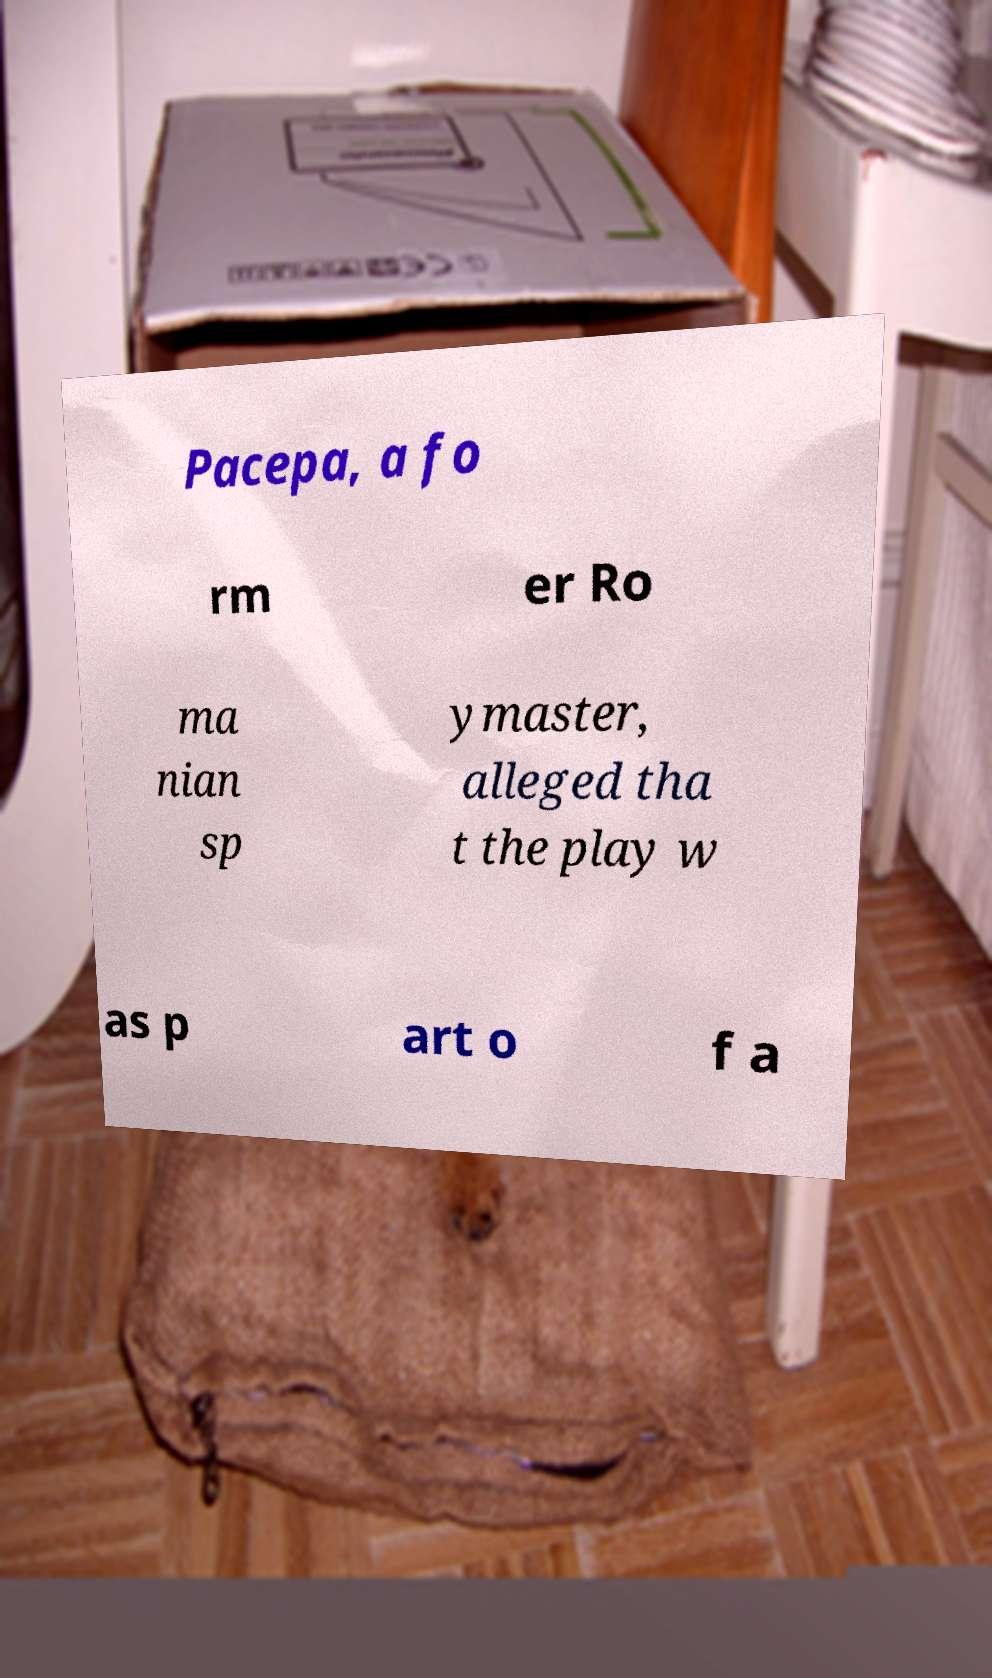Can you read and provide the text displayed in the image?This photo seems to have some interesting text. Can you extract and type it out for me? Pacepa, a fo rm er Ro ma nian sp ymaster, alleged tha t the play w as p art o f a 